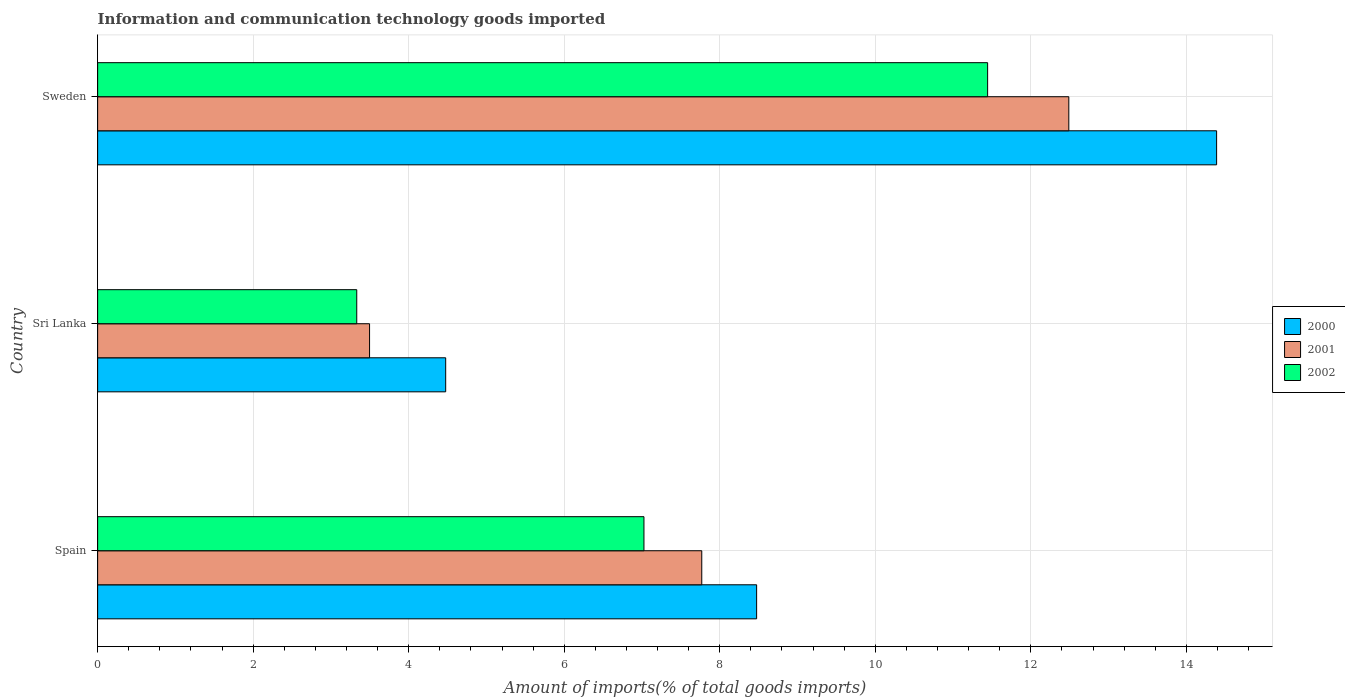Are the number of bars on each tick of the Y-axis equal?
Your answer should be compact. Yes. How many bars are there on the 1st tick from the top?
Make the answer very short. 3. What is the label of the 1st group of bars from the top?
Offer a terse response. Sweden. In how many cases, is the number of bars for a given country not equal to the number of legend labels?
Offer a terse response. 0. What is the amount of goods imported in 2002 in Sweden?
Ensure brevity in your answer.  11.45. Across all countries, what is the maximum amount of goods imported in 2000?
Provide a short and direct response. 14.39. Across all countries, what is the minimum amount of goods imported in 2002?
Offer a very short reply. 3.33. In which country was the amount of goods imported in 2001 maximum?
Your answer should be compact. Sweden. In which country was the amount of goods imported in 2000 minimum?
Make the answer very short. Sri Lanka. What is the total amount of goods imported in 2000 in the graph?
Keep it short and to the point. 27.34. What is the difference between the amount of goods imported in 2000 in Sri Lanka and that in Sweden?
Make the answer very short. -9.91. What is the difference between the amount of goods imported in 2001 in Sri Lanka and the amount of goods imported in 2002 in Spain?
Your answer should be compact. -3.53. What is the average amount of goods imported in 2002 per country?
Provide a short and direct response. 7.27. What is the difference between the amount of goods imported in 2002 and amount of goods imported in 2001 in Spain?
Keep it short and to the point. -0.74. In how many countries, is the amount of goods imported in 2001 greater than 10 %?
Provide a succinct answer. 1. What is the ratio of the amount of goods imported in 2001 in Spain to that in Sri Lanka?
Your answer should be compact. 2.22. Is the difference between the amount of goods imported in 2002 in Sri Lanka and Sweden greater than the difference between the amount of goods imported in 2001 in Sri Lanka and Sweden?
Your response must be concise. Yes. What is the difference between the highest and the second highest amount of goods imported in 2002?
Your answer should be compact. 4.42. What is the difference between the highest and the lowest amount of goods imported in 2001?
Offer a terse response. 8.99. Is the sum of the amount of goods imported in 2001 in Spain and Sri Lanka greater than the maximum amount of goods imported in 2002 across all countries?
Your answer should be compact. No. What does the 1st bar from the bottom in Sweden represents?
Your answer should be compact. 2000. How many bars are there?
Provide a succinct answer. 9. Are all the bars in the graph horizontal?
Keep it short and to the point. Yes. How many countries are there in the graph?
Your response must be concise. 3. Are the values on the major ticks of X-axis written in scientific E-notation?
Ensure brevity in your answer.  No. Does the graph contain grids?
Keep it short and to the point. Yes. What is the title of the graph?
Offer a terse response. Information and communication technology goods imported. What is the label or title of the X-axis?
Your response must be concise. Amount of imports(% of total goods imports). What is the label or title of the Y-axis?
Ensure brevity in your answer.  Country. What is the Amount of imports(% of total goods imports) in 2000 in Spain?
Your response must be concise. 8.47. What is the Amount of imports(% of total goods imports) in 2001 in Spain?
Your answer should be compact. 7.77. What is the Amount of imports(% of total goods imports) in 2002 in Spain?
Offer a terse response. 7.03. What is the Amount of imports(% of total goods imports) of 2000 in Sri Lanka?
Offer a terse response. 4.48. What is the Amount of imports(% of total goods imports) of 2001 in Sri Lanka?
Your answer should be very brief. 3.5. What is the Amount of imports(% of total goods imports) of 2002 in Sri Lanka?
Provide a succinct answer. 3.33. What is the Amount of imports(% of total goods imports) of 2000 in Sweden?
Provide a succinct answer. 14.39. What is the Amount of imports(% of total goods imports) of 2001 in Sweden?
Ensure brevity in your answer.  12.49. What is the Amount of imports(% of total goods imports) of 2002 in Sweden?
Provide a succinct answer. 11.45. Across all countries, what is the maximum Amount of imports(% of total goods imports) of 2000?
Ensure brevity in your answer.  14.39. Across all countries, what is the maximum Amount of imports(% of total goods imports) of 2001?
Provide a succinct answer. 12.49. Across all countries, what is the maximum Amount of imports(% of total goods imports) of 2002?
Offer a terse response. 11.45. Across all countries, what is the minimum Amount of imports(% of total goods imports) in 2000?
Keep it short and to the point. 4.48. Across all countries, what is the minimum Amount of imports(% of total goods imports) of 2001?
Keep it short and to the point. 3.5. Across all countries, what is the minimum Amount of imports(% of total goods imports) of 2002?
Offer a terse response. 3.33. What is the total Amount of imports(% of total goods imports) in 2000 in the graph?
Ensure brevity in your answer.  27.34. What is the total Amount of imports(% of total goods imports) in 2001 in the graph?
Your response must be concise. 23.75. What is the total Amount of imports(% of total goods imports) in 2002 in the graph?
Make the answer very short. 21.8. What is the difference between the Amount of imports(% of total goods imports) of 2000 in Spain and that in Sri Lanka?
Offer a terse response. 4. What is the difference between the Amount of imports(% of total goods imports) of 2001 in Spain and that in Sri Lanka?
Your answer should be very brief. 4.27. What is the difference between the Amount of imports(% of total goods imports) in 2002 in Spain and that in Sri Lanka?
Your answer should be compact. 3.69. What is the difference between the Amount of imports(% of total goods imports) in 2000 in Spain and that in Sweden?
Offer a terse response. -5.92. What is the difference between the Amount of imports(% of total goods imports) of 2001 in Spain and that in Sweden?
Provide a short and direct response. -4.72. What is the difference between the Amount of imports(% of total goods imports) of 2002 in Spain and that in Sweden?
Offer a very short reply. -4.42. What is the difference between the Amount of imports(% of total goods imports) of 2000 in Sri Lanka and that in Sweden?
Offer a terse response. -9.91. What is the difference between the Amount of imports(% of total goods imports) in 2001 in Sri Lanka and that in Sweden?
Give a very brief answer. -8.99. What is the difference between the Amount of imports(% of total goods imports) in 2002 in Sri Lanka and that in Sweden?
Provide a succinct answer. -8.11. What is the difference between the Amount of imports(% of total goods imports) of 2000 in Spain and the Amount of imports(% of total goods imports) of 2001 in Sri Lanka?
Provide a short and direct response. 4.98. What is the difference between the Amount of imports(% of total goods imports) of 2000 in Spain and the Amount of imports(% of total goods imports) of 2002 in Sri Lanka?
Offer a very short reply. 5.14. What is the difference between the Amount of imports(% of total goods imports) of 2001 in Spain and the Amount of imports(% of total goods imports) of 2002 in Sri Lanka?
Your answer should be compact. 4.44. What is the difference between the Amount of imports(% of total goods imports) of 2000 in Spain and the Amount of imports(% of total goods imports) of 2001 in Sweden?
Provide a succinct answer. -4.01. What is the difference between the Amount of imports(% of total goods imports) of 2000 in Spain and the Amount of imports(% of total goods imports) of 2002 in Sweden?
Offer a terse response. -2.97. What is the difference between the Amount of imports(% of total goods imports) in 2001 in Spain and the Amount of imports(% of total goods imports) in 2002 in Sweden?
Give a very brief answer. -3.68. What is the difference between the Amount of imports(% of total goods imports) of 2000 in Sri Lanka and the Amount of imports(% of total goods imports) of 2001 in Sweden?
Offer a terse response. -8.01. What is the difference between the Amount of imports(% of total goods imports) of 2000 in Sri Lanka and the Amount of imports(% of total goods imports) of 2002 in Sweden?
Provide a short and direct response. -6.97. What is the difference between the Amount of imports(% of total goods imports) in 2001 in Sri Lanka and the Amount of imports(% of total goods imports) in 2002 in Sweden?
Offer a very short reply. -7.95. What is the average Amount of imports(% of total goods imports) of 2000 per country?
Provide a succinct answer. 9.11. What is the average Amount of imports(% of total goods imports) of 2001 per country?
Ensure brevity in your answer.  7.92. What is the average Amount of imports(% of total goods imports) of 2002 per country?
Ensure brevity in your answer.  7.27. What is the difference between the Amount of imports(% of total goods imports) in 2000 and Amount of imports(% of total goods imports) in 2001 in Spain?
Offer a very short reply. 0.71. What is the difference between the Amount of imports(% of total goods imports) of 2000 and Amount of imports(% of total goods imports) of 2002 in Spain?
Your answer should be very brief. 1.45. What is the difference between the Amount of imports(% of total goods imports) in 2001 and Amount of imports(% of total goods imports) in 2002 in Spain?
Provide a succinct answer. 0.74. What is the difference between the Amount of imports(% of total goods imports) of 2000 and Amount of imports(% of total goods imports) of 2001 in Sri Lanka?
Provide a short and direct response. 0.98. What is the difference between the Amount of imports(% of total goods imports) in 2000 and Amount of imports(% of total goods imports) in 2002 in Sri Lanka?
Make the answer very short. 1.14. What is the difference between the Amount of imports(% of total goods imports) in 2001 and Amount of imports(% of total goods imports) in 2002 in Sri Lanka?
Your answer should be very brief. 0.16. What is the difference between the Amount of imports(% of total goods imports) in 2000 and Amount of imports(% of total goods imports) in 2001 in Sweden?
Offer a very short reply. 1.9. What is the difference between the Amount of imports(% of total goods imports) of 2000 and Amount of imports(% of total goods imports) of 2002 in Sweden?
Give a very brief answer. 2.94. What is the difference between the Amount of imports(% of total goods imports) in 2001 and Amount of imports(% of total goods imports) in 2002 in Sweden?
Offer a terse response. 1.04. What is the ratio of the Amount of imports(% of total goods imports) in 2000 in Spain to that in Sri Lanka?
Make the answer very short. 1.89. What is the ratio of the Amount of imports(% of total goods imports) in 2001 in Spain to that in Sri Lanka?
Your answer should be very brief. 2.22. What is the ratio of the Amount of imports(% of total goods imports) of 2002 in Spain to that in Sri Lanka?
Make the answer very short. 2.11. What is the ratio of the Amount of imports(% of total goods imports) of 2000 in Spain to that in Sweden?
Provide a short and direct response. 0.59. What is the ratio of the Amount of imports(% of total goods imports) in 2001 in Spain to that in Sweden?
Your answer should be compact. 0.62. What is the ratio of the Amount of imports(% of total goods imports) of 2002 in Spain to that in Sweden?
Offer a terse response. 0.61. What is the ratio of the Amount of imports(% of total goods imports) in 2000 in Sri Lanka to that in Sweden?
Provide a succinct answer. 0.31. What is the ratio of the Amount of imports(% of total goods imports) of 2001 in Sri Lanka to that in Sweden?
Your response must be concise. 0.28. What is the ratio of the Amount of imports(% of total goods imports) in 2002 in Sri Lanka to that in Sweden?
Keep it short and to the point. 0.29. What is the difference between the highest and the second highest Amount of imports(% of total goods imports) of 2000?
Keep it short and to the point. 5.92. What is the difference between the highest and the second highest Amount of imports(% of total goods imports) in 2001?
Give a very brief answer. 4.72. What is the difference between the highest and the second highest Amount of imports(% of total goods imports) in 2002?
Ensure brevity in your answer.  4.42. What is the difference between the highest and the lowest Amount of imports(% of total goods imports) in 2000?
Make the answer very short. 9.91. What is the difference between the highest and the lowest Amount of imports(% of total goods imports) in 2001?
Offer a terse response. 8.99. What is the difference between the highest and the lowest Amount of imports(% of total goods imports) of 2002?
Offer a very short reply. 8.11. 